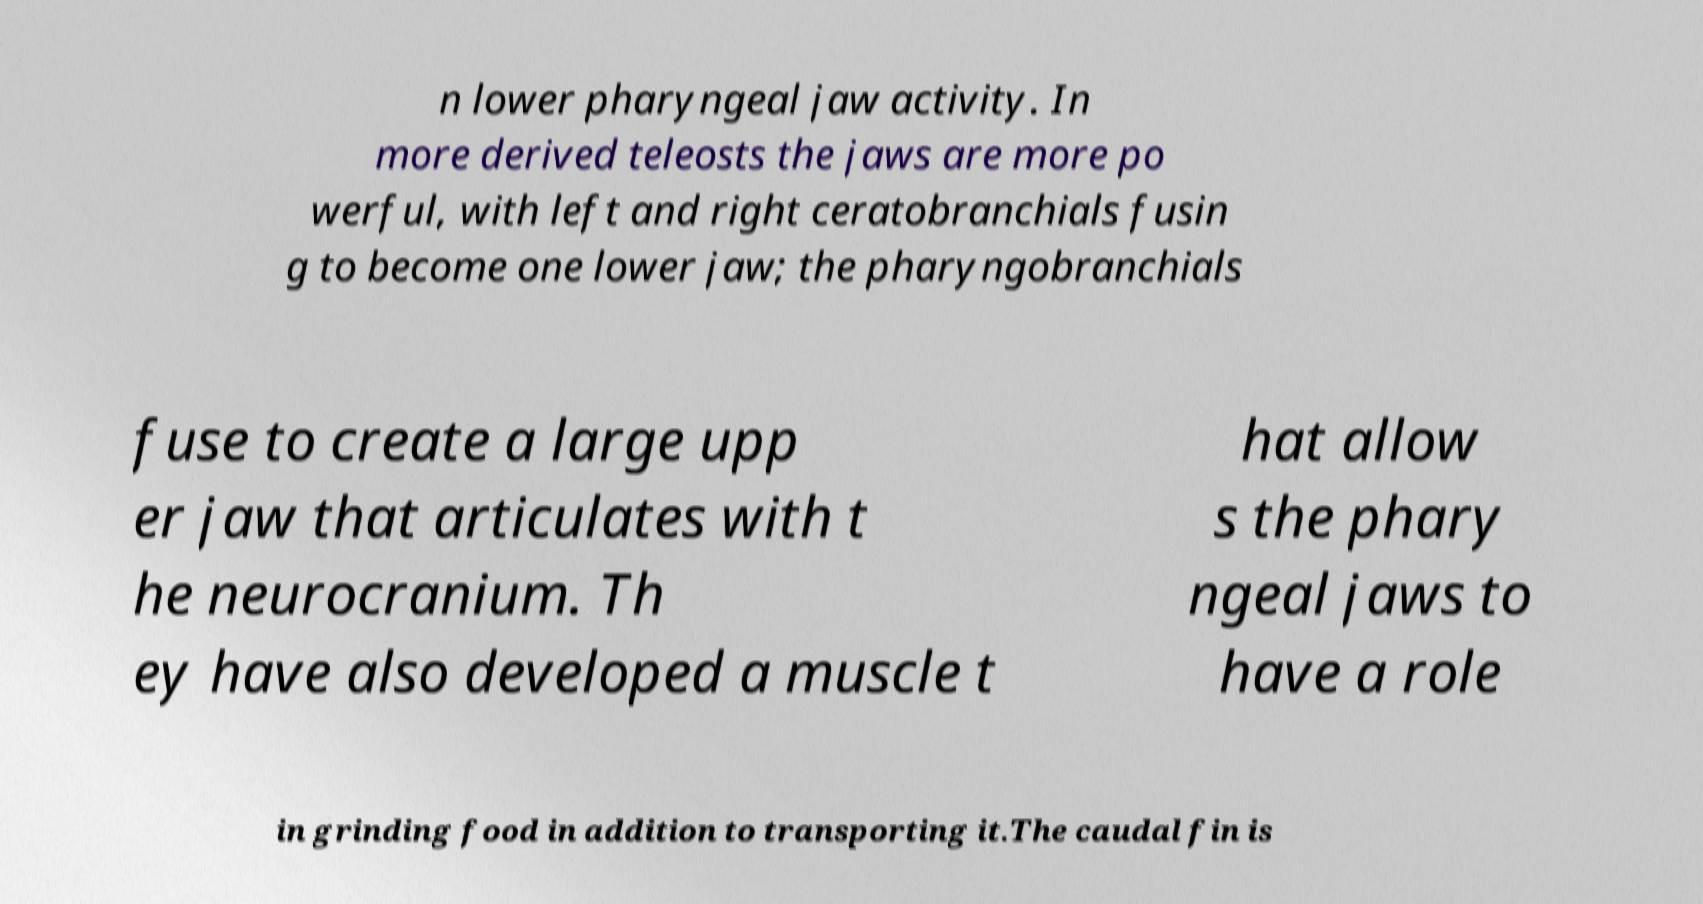Could you extract and type out the text from this image? n lower pharyngeal jaw activity. In more derived teleosts the jaws are more po werful, with left and right ceratobranchials fusin g to become one lower jaw; the pharyngobranchials fuse to create a large upp er jaw that articulates with t he neurocranium. Th ey have also developed a muscle t hat allow s the phary ngeal jaws to have a role in grinding food in addition to transporting it.The caudal fin is 